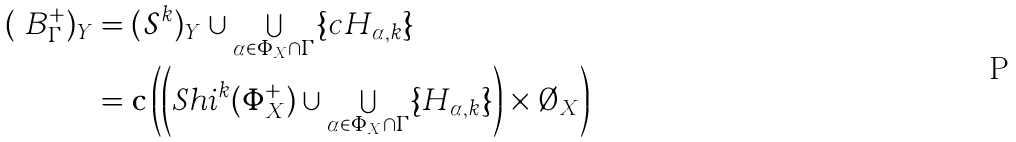Convert formula to latex. <formula><loc_0><loc_0><loc_500><loc_500>( \ B _ { \Gamma } ^ { + } ) _ { Y } & = ( { \mathcal { S } } ^ { k } ) _ { Y } \cup \bigcup _ { \alpha \in \Phi _ { X } \cap \Gamma } \{ c H _ { \alpha , k } \} \\ & = { \mathbf c } \left ( \left ( S h i ^ { k } ( \Phi ^ { + } _ { X } ) \cup \bigcup _ { \alpha \in \Phi _ { X } \cap \Gamma } \{ H _ { \alpha , k } \} \right ) \times \emptyset _ { X } \right )</formula> 